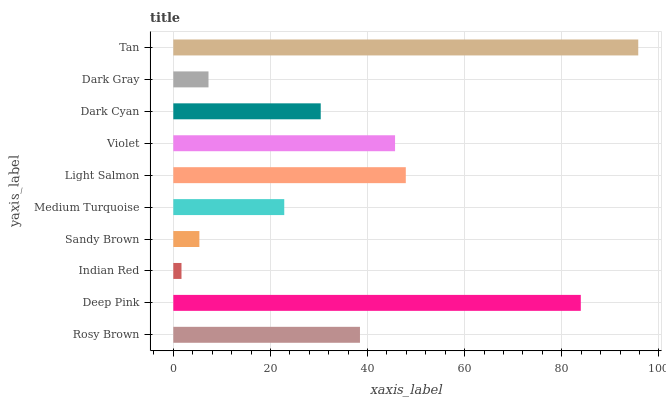Is Indian Red the minimum?
Answer yes or no. Yes. Is Tan the maximum?
Answer yes or no. Yes. Is Deep Pink the minimum?
Answer yes or no. No. Is Deep Pink the maximum?
Answer yes or no. No. Is Deep Pink greater than Rosy Brown?
Answer yes or no. Yes. Is Rosy Brown less than Deep Pink?
Answer yes or no. Yes. Is Rosy Brown greater than Deep Pink?
Answer yes or no. No. Is Deep Pink less than Rosy Brown?
Answer yes or no. No. Is Rosy Brown the high median?
Answer yes or no. Yes. Is Dark Cyan the low median?
Answer yes or no. Yes. Is Deep Pink the high median?
Answer yes or no. No. Is Rosy Brown the low median?
Answer yes or no. No. 